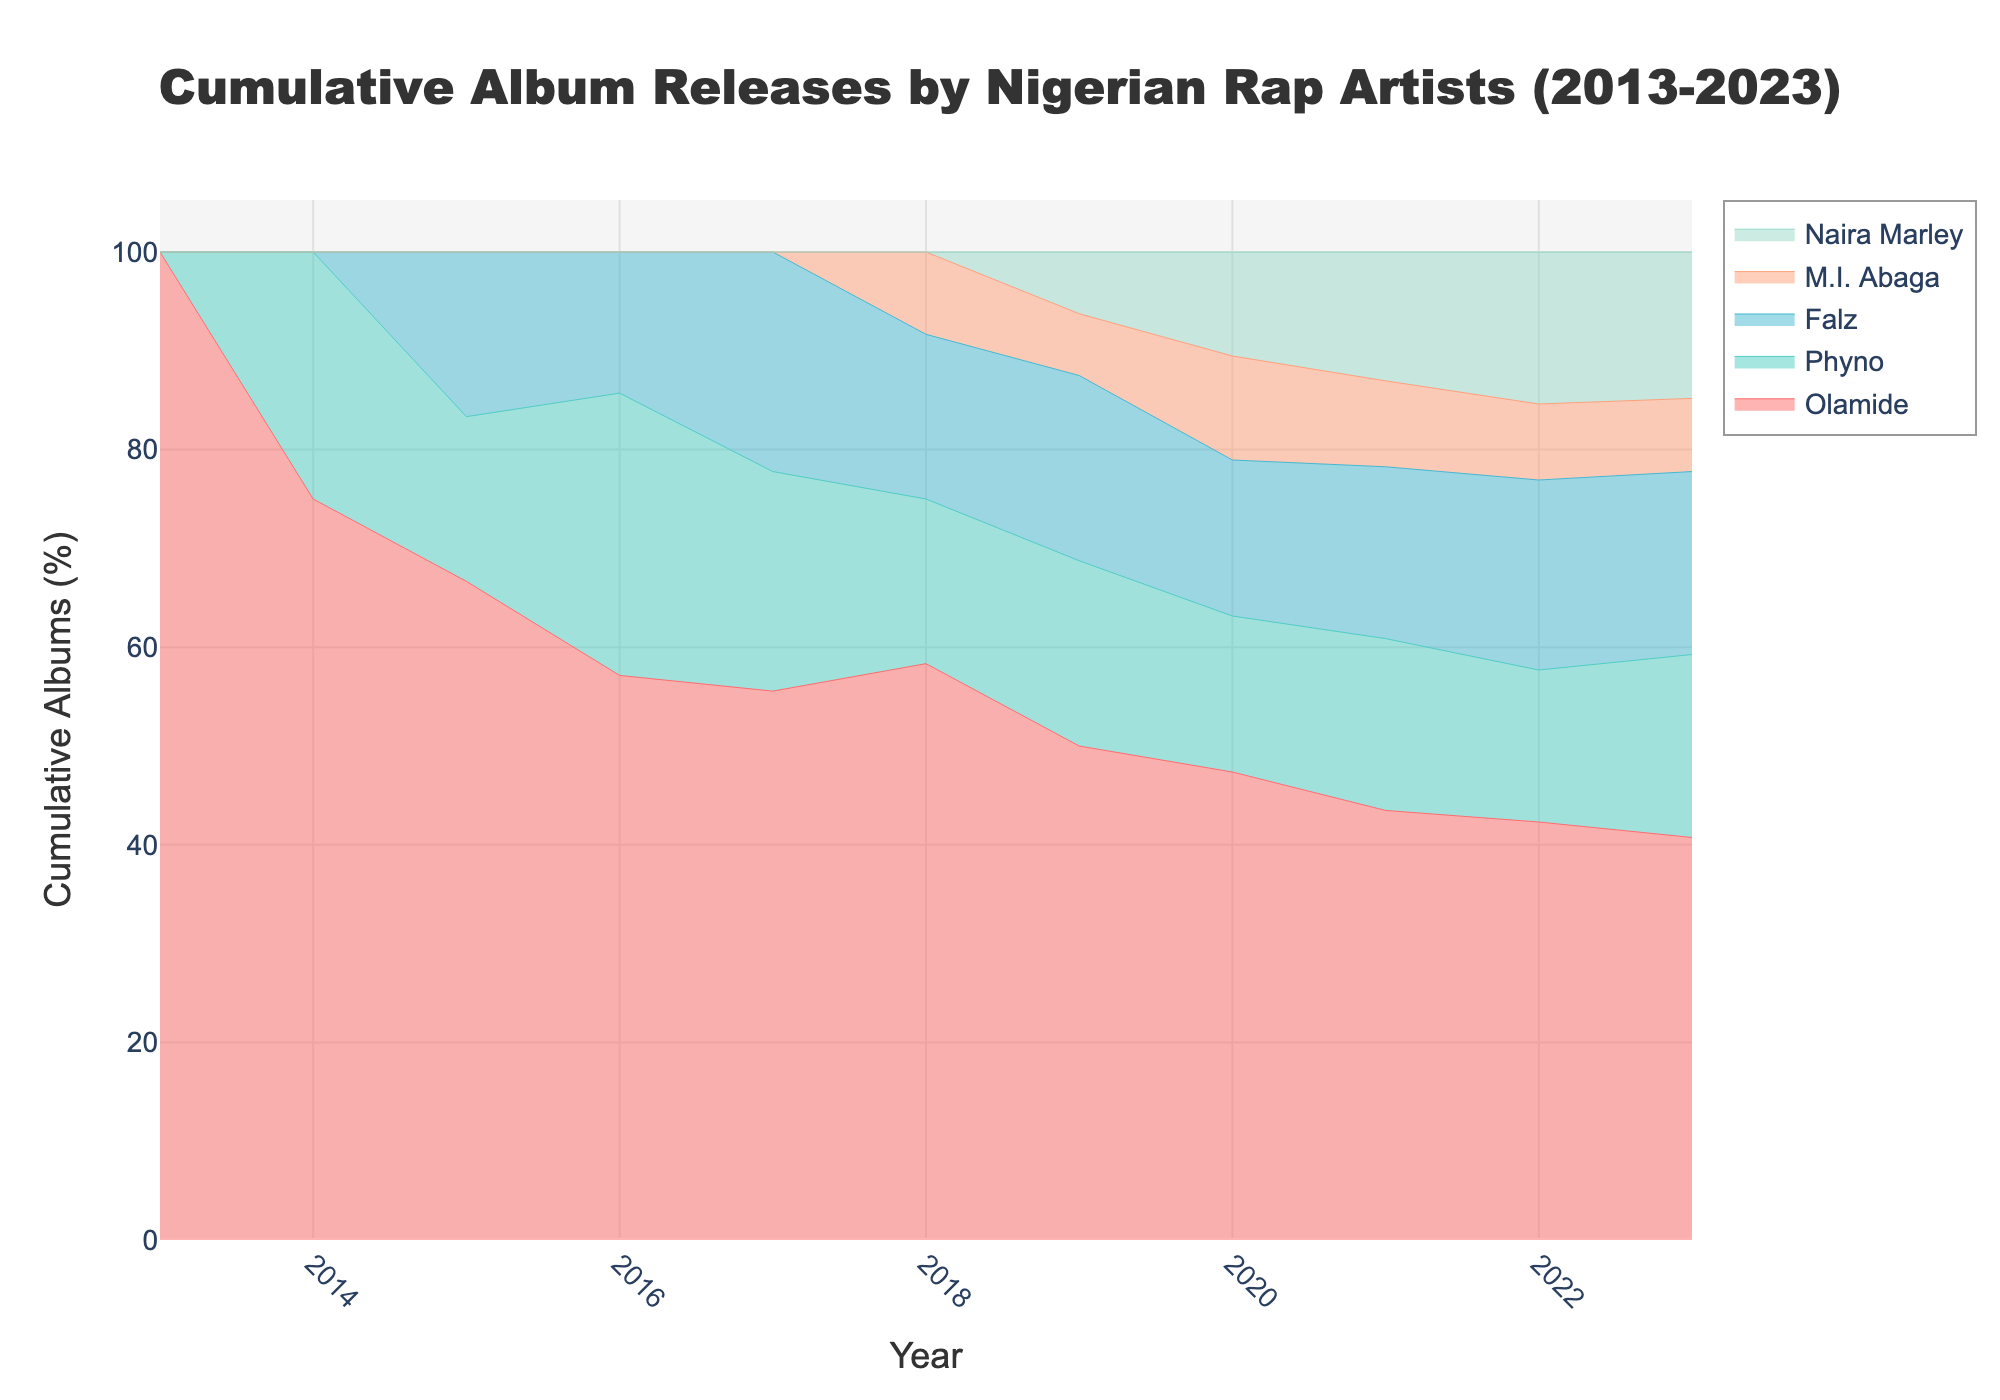What is the title of the chart? The title of the chart is mentioned at the top of the figure. It is prominently displayed in a large font size to indicate the main topic of the plot.
Answer: Cumulative Album Releases by Nigerian Rap Artists (2013-2023) Which artist has the most cumulative album releases by 2023? To answer this, look at the highest point in 2023 and observe which artist's line corresponds to this point.
Answer: Olamide How many albums had Olamide released cumulatively by 2016? Identify Olamide's line on the chart and find the value corresponding to the year 2016.
Answer: 4 albums In which year did Falz start releasing albums? Locate the starting point of Falz's line on the chart, then determine the corresponding year on the x-axis.
Answer: 2015 How many albums did Phyno release in 2019? Find the incremental increase in Phyno's line between 2018 and 2019 on the chart. This increase represents the number of albums released in 2019.
Answer: 1 album Which artist has the steepest climb in their cumulative album releases? Observe the slopes of the lines on the chart and identify which artist has the steepest increase overall.
Answer: Olamide How does the cumulative album release of Phyno compare to Falz by 2020? Find the cumulative values for both Phyno and Falz in the year 2020 and compare them directly.
Answer: Phyno released more albums cumulatively (4) compared to Falz (3) by 2020 Between 2018 and 2021, which artist showed the most significant increase in album releases? Calculate the difference in cumulative albums for each artist from 2018 to 2021, and identify the artist with the largest increase.
Answer: Olamide How many total albums were released by all artists in 2019? Check the overall increments in the cumulative data for each artist within 2019, add these increments together to find the total.
Answer: 4 albums 